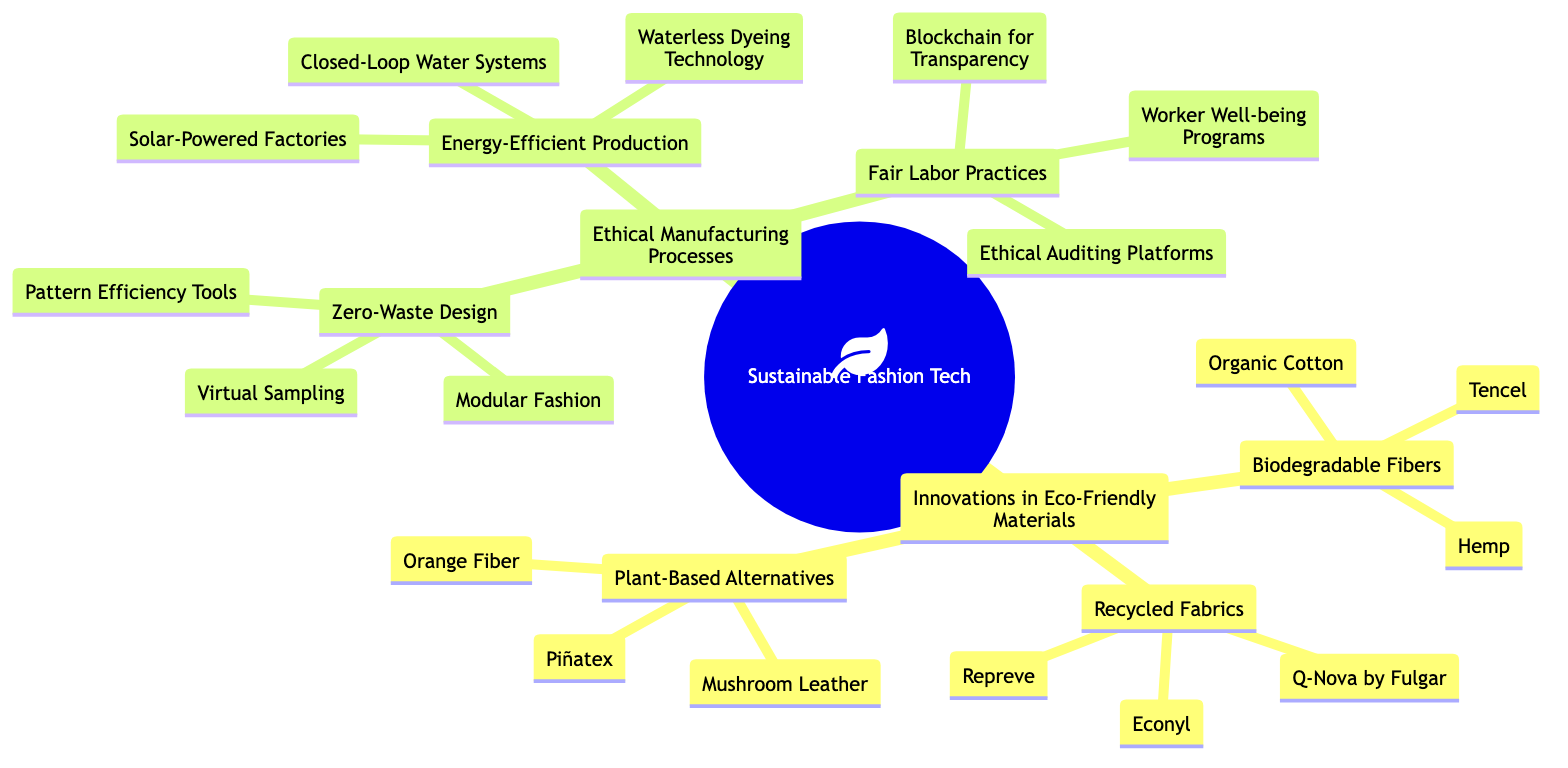What are the three categories under Innovations in Eco-Friendly Materials? The diagram lists three categories under Innovations in Eco-Friendly Materials: Recycled Fabrics, Biodegradable Fibers, and Plant-Based Alternatives. Each of these branches has specific examples listed beneath them.
Answer: Recycled Fabrics, Biodegradable Fibers, Plant-Based Alternatives How many types of Recycled Fabrics are mentioned? The diagram shows three specific types of Recycled Fabrics: Econyl, Repreve, and Q-Nova by Fulgar. Counting them provides the answer.
Answer: 3 What technology is used for Waterless Dyeing? The diagram indicates that Waterless Dyeing Technology is an example of Energy-Efficient Production. It explicitly lists Dyecoo as the technology used for this process.
Answer: Dyecoo Which category does Blockchain for Transparency belong to? The diagram categorizes Blockchain for Transparency under Fair Labor Practices, indicating its role in promoting ethical manufacturing processes.
Answer: Fair Labor Practices List an example of Plant-Based Alternatives. Under the category of Plant-Based Alternatives, the diagram provides three specific examples: Piñatex, Mushroom Leather, and Orange Fiber. Choosing any one of them answers the question.
Answer: Piñatex What is a zero-waste design method mentioned? The diagram lists several methods under Zero-Waste Design. One method is Pattern Efficiency Tools, which is specifically called out as a strategy in this context.
Answer: Pattern Efficiency Tools How many types of Biodegradable Fibers are listed? The diagram shows three examples under Biodegradable Fibers: Tencel, Organic Cotton, and Hemp. Counting these items yields the answer.
Answer: 3 What is one benefit of Solar-Powered Factories? While the diagram does not explicitly state benefits, it suggests that Solar-Powered Factories fall under Energy-Efficient Production, implying sustainability and reduced energy impact are benefits.
Answer: Sustainability Which example falls under Worker Well-being Programs? The diagram includes Worker Well-being Programs as a category, with examples listed such as Good On You, indicating a specific program focused on workers' rights and well-being.
Answer: Good On You 